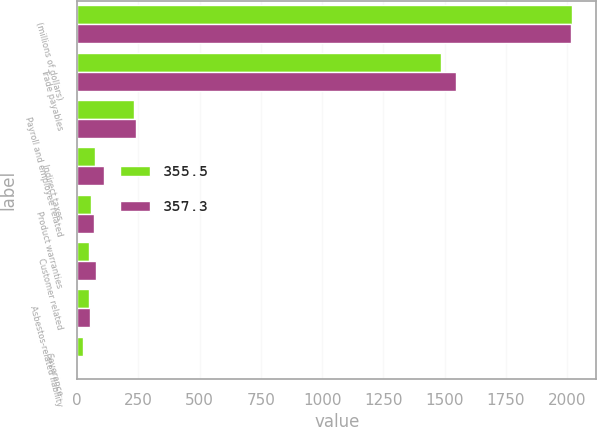<chart> <loc_0><loc_0><loc_500><loc_500><stacked_bar_chart><ecel><fcel>(millions of dollars)<fcel>Trade payables<fcel>Payroll and employee related<fcel>Indirect taxes<fcel>Product warranties<fcel>Customer related<fcel>Asbestos-related liability<fcel>Severance<nl><fcel>355.5<fcel>2018<fcel>1485.4<fcel>232.6<fcel>72.9<fcel>56.2<fcel>49.2<fcel>50<fcel>25<nl><fcel>357.3<fcel>2017<fcel>1545.6<fcel>239.7<fcel>111<fcel>69<fcel>75.7<fcel>52.5<fcel>5.8<nl></chart> 